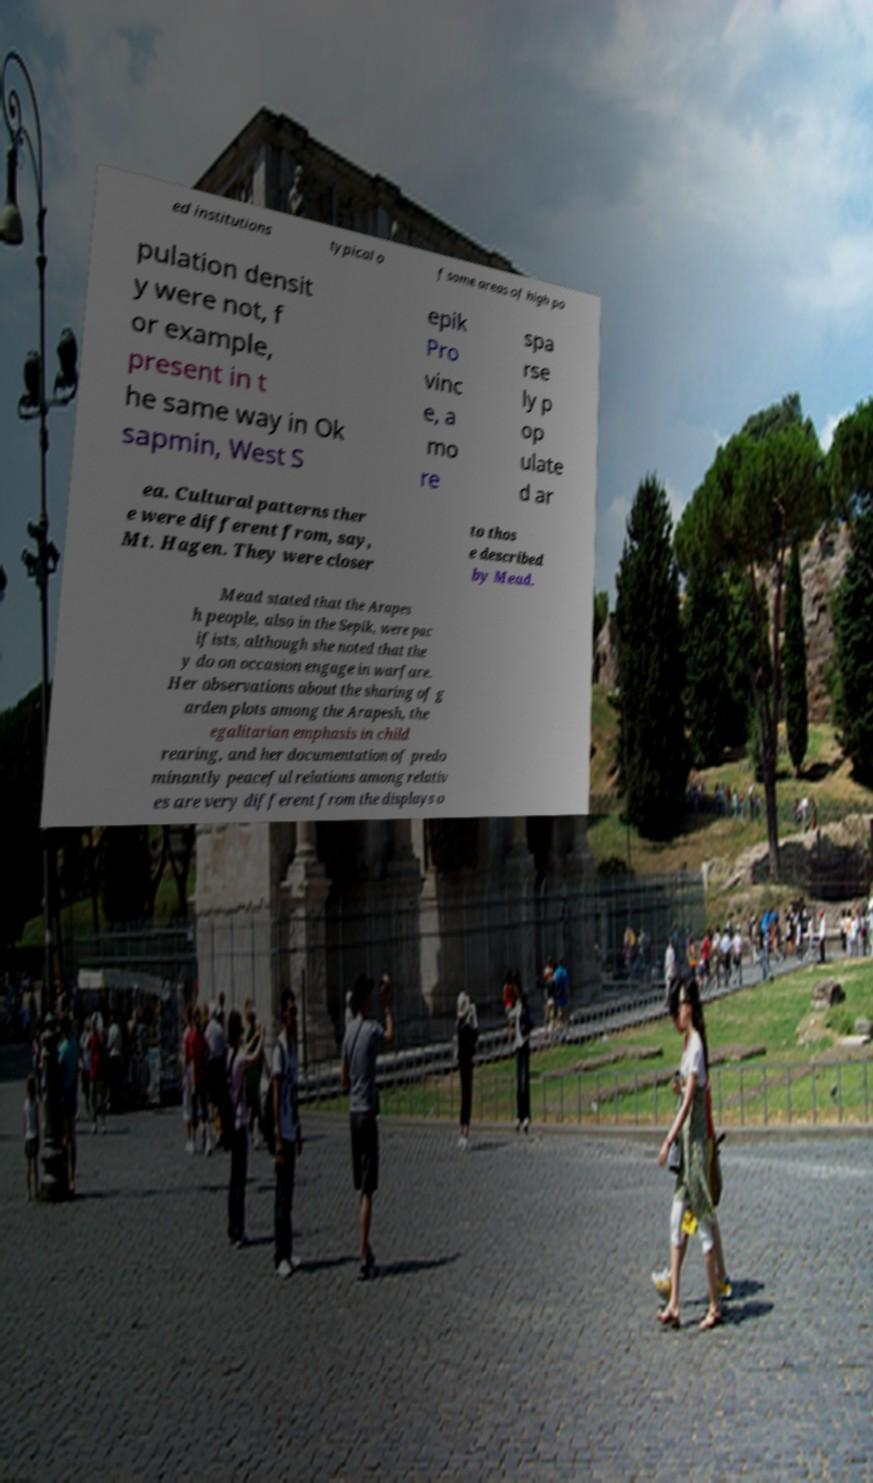Please identify and transcribe the text found in this image. ed institutions typical o f some areas of high po pulation densit y were not, f or example, present in t he same way in Ok sapmin, West S epik Pro vinc e, a mo re spa rse ly p op ulate d ar ea. Cultural patterns ther e were different from, say, Mt. Hagen. They were closer to thos e described by Mead. Mead stated that the Arapes h people, also in the Sepik, were pac ifists, although she noted that the y do on occasion engage in warfare. Her observations about the sharing of g arden plots among the Arapesh, the egalitarian emphasis in child rearing, and her documentation of predo minantly peaceful relations among relativ es are very different from the displays o 